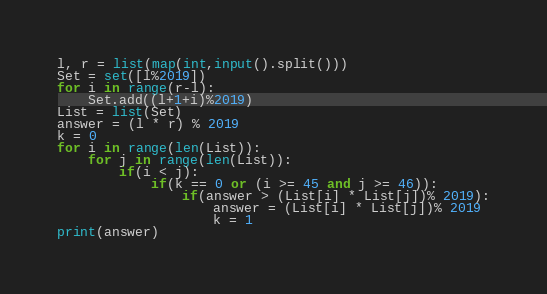Convert code to text. <code><loc_0><loc_0><loc_500><loc_500><_Python_>l, r = list(map(int,input().split()))
Set = set([l%2019])
for i in range(r-l):
	Set.add((l+1+i)%2019)
List = list(Set)
answer = (l * r) % 2019
k = 0
for i in range(len(List)):
	for j in range(len(List)):
		if(i < j):
			if(k == 0 or (i >= 45 and j >= 46)):
				if(answer > (List[i] * List[j])% 2019):
					answer = (List[i] * List[j])% 2019
					k = 1
print(answer)</code> 